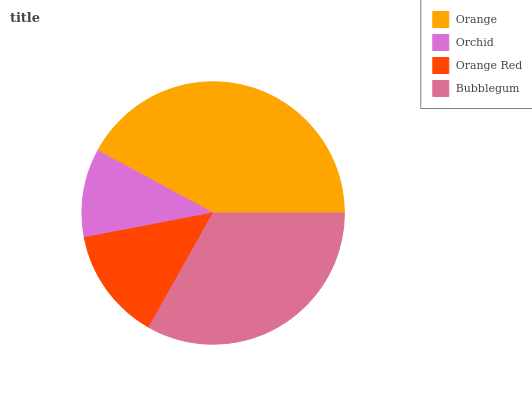Is Orchid the minimum?
Answer yes or no. Yes. Is Orange the maximum?
Answer yes or no. Yes. Is Orange Red the minimum?
Answer yes or no. No. Is Orange Red the maximum?
Answer yes or no. No. Is Orange Red greater than Orchid?
Answer yes or no. Yes. Is Orchid less than Orange Red?
Answer yes or no. Yes. Is Orchid greater than Orange Red?
Answer yes or no. No. Is Orange Red less than Orchid?
Answer yes or no. No. Is Bubblegum the high median?
Answer yes or no. Yes. Is Orange Red the low median?
Answer yes or no. Yes. Is Orange Red the high median?
Answer yes or no. No. Is Orchid the low median?
Answer yes or no. No. 